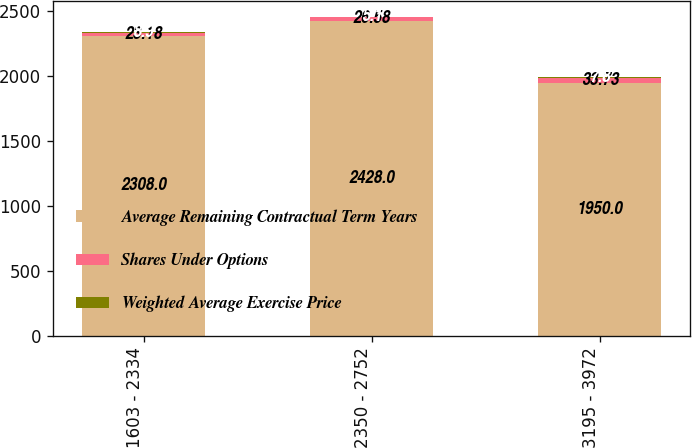<chart> <loc_0><loc_0><loc_500><loc_500><stacked_bar_chart><ecel><fcel>1603 - 2334<fcel>2350 - 2752<fcel>3195 - 3972<nl><fcel>Average Remaining Contractual Term Years<fcel>2308<fcel>2428<fcel>1950<nl><fcel>Shares Under Options<fcel>23.18<fcel>26.58<fcel>33.73<nl><fcel>Weighted Average Exercise Price<fcel>8.9<fcel>5.1<fcel>7.8<nl></chart> 